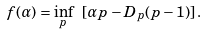Convert formula to latex. <formula><loc_0><loc_0><loc_500><loc_500>f ( \alpha ) = \inf _ { p } \ [ \alpha p - D _ { p } ( p - 1 ) ] \, .</formula> 